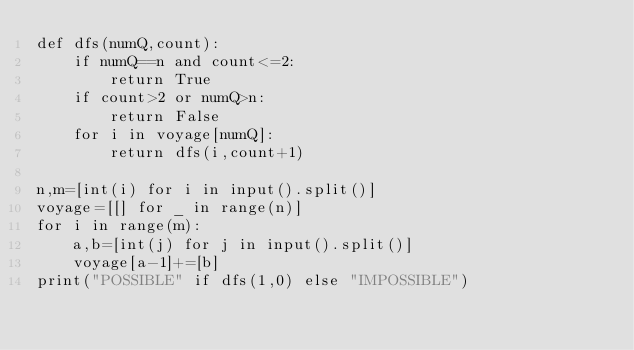Convert code to text. <code><loc_0><loc_0><loc_500><loc_500><_Python_>def dfs(numQ,count):
    if numQ==n and count<=2:
        return True
    if count>2 or numQ>n:
        return False
    for i in voyage[numQ]:
        return dfs(i,count+1)

n,m=[int(i) for i in input().split()]
voyage=[[] for _ in range(n)]
for i in range(m):
    a,b=[int(j) for j in input().split()]
    voyage[a-1]+=[b]
print("POSSIBLE" if dfs(1,0) else "IMPOSSIBLE")</code> 